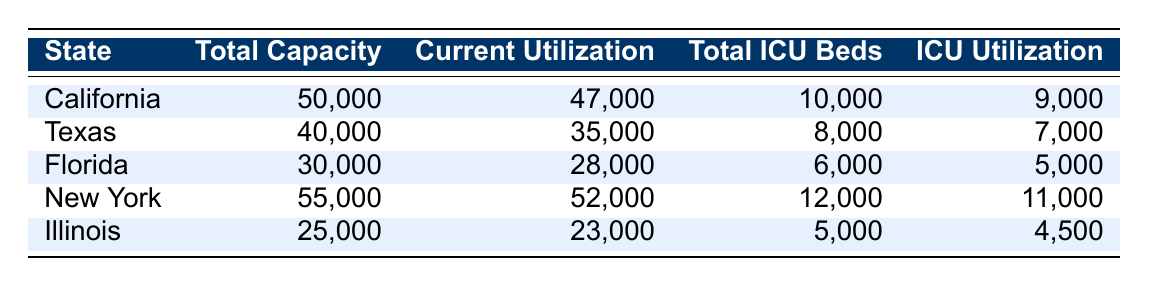What is the total capacity of hospitals in Florida? The table lists Florida as having a total hospital capacity of 30,000. This value can be found directly under the "Total Capacity" column for Florida.
Answer: 30,000 What is the current utilization of hospitals in California? The table indicates the current utilization for California’s hospitals is 47,000, which is directly presented in the "Current Utilization" column for that state.
Answer: 47,000 Which state has the highest current ICU utilization? By examining the "ICU Utilization" column, New York shows the highest value at 11,000, revealing it has the most utilized ICU beds compared to other states.
Answer: New York What is the total number of ICU beds in hospitals across all states provided in the table? Summing the total ICU beds for each state: 10,000 (California) + 8,000 (Texas) + 6,000 (Florida) + 12,000 (New York) + 5,000 (Illinois) equals a total of 41,000 ICU beds.
Answer: 41,000 Is the current hospital utilization in Texas greater than 75% of its total capacity? The current utilization in Texas is 35,000 out of a total capacity of 40,000. To check: (35,000/40,000) * 100 = 87.5%, which is greater than 75%.
Answer: Yes What is the difference between total capacity and current utilization for hospitals in Illinois? For Illinois, the total capacity is 25,000 and current utilization is 23,000. The difference is 25,000 - 23,000 = 2,000.
Answer: 2,000 Which state has the lowest total capacity for hospitals? Referencing the "Total Capacity" column, Illinois has the lowest capacity at 25,000 compared to other states listed in the table.
Answer: Illinois What percentage of ICU beds are currently utilized in Florida? The current ICU utilization for Florida is 5,000 out of a total of 6,000 ICU beds. To find the percentage: (5,000/6,000) * 100 = 83.33%.
Answer: 83.33% 